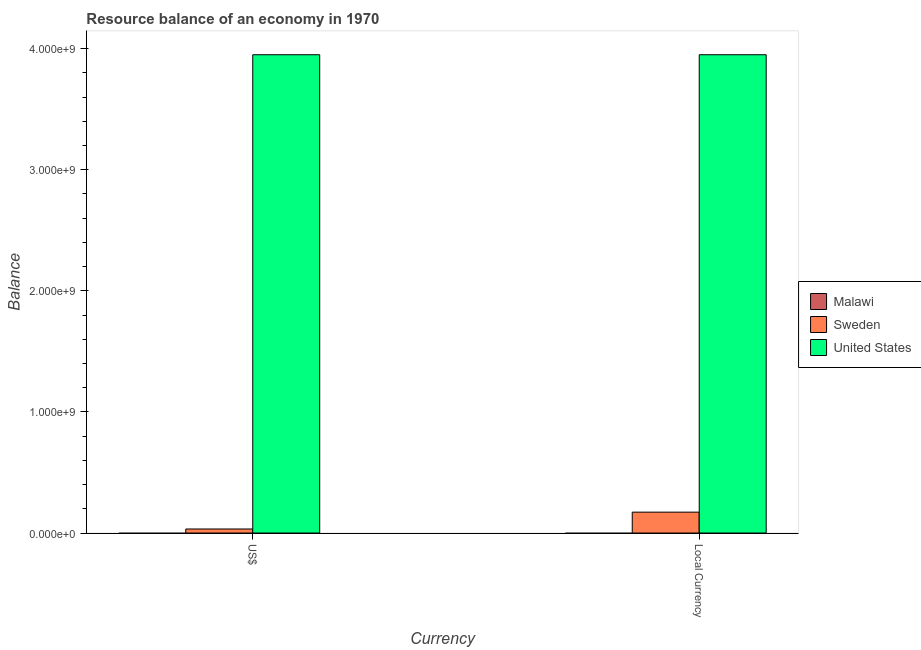How many different coloured bars are there?
Offer a terse response. 2. Are the number of bars per tick equal to the number of legend labels?
Provide a short and direct response. No. Are the number of bars on each tick of the X-axis equal?
Offer a terse response. Yes. How many bars are there on the 2nd tick from the right?
Offer a very short reply. 2. What is the label of the 2nd group of bars from the left?
Ensure brevity in your answer.  Local Currency. Across all countries, what is the maximum resource balance in us$?
Give a very brief answer. 3.95e+09. What is the total resource balance in us$ in the graph?
Keep it short and to the point. 3.98e+09. What is the difference between the resource balance in constant us$ in United States and that in Sweden?
Give a very brief answer. 3.78e+09. What is the difference between the resource balance in us$ in Sweden and the resource balance in constant us$ in Malawi?
Offer a terse response. 3.33e+07. What is the average resource balance in constant us$ per country?
Offer a very short reply. 1.37e+09. In how many countries, is the resource balance in us$ greater than 2400000000 units?
Make the answer very short. 1. What is the ratio of the resource balance in us$ in Sweden to that in United States?
Your answer should be very brief. 0.01. How many countries are there in the graph?
Keep it short and to the point. 3. What is the difference between two consecutive major ticks on the Y-axis?
Provide a succinct answer. 1.00e+09. Are the values on the major ticks of Y-axis written in scientific E-notation?
Provide a short and direct response. Yes. Does the graph contain grids?
Your response must be concise. No. How are the legend labels stacked?
Your answer should be very brief. Vertical. What is the title of the graph?
Ensure brevity in your answer.  Resource balance of an economy in 1970. Does "New Zealand" appear as one of the legend labels in the graph?
Offer a very short reply. No. What is the label or title of the X-axis?
Offer a very short reply. Currency. What is the label or title of the Y-axis?
Offer a terse response. Balance. What is the Balance of Sweden in US$?
Your response must be concise. 3.33e+07. What is the Balance of United States in US$?
Your answer should be very brief. 3.95e+09. What is the Balance in Sweden in Local Currency?
Your response must be concise. 1.72e+08. What is the Balance in United States in Local Currency?
Give a very brief answer. 3.95e+09. Across all Currency, what is the maximum Balance of Sweden?
Provide a succinct answer. 1.72e+08. Across all Currency, what is the maximum Balance of United States?
Your answer should be very brief. 3.95e+09. Across all Currency, what is the minimum Balance in Sweden?
Give a very brief answer. 3.33e+07. Across all Currency, what is the minimum Balance in United States?
Give a very brief answer. 3.95e+09. What is the total Balance of Malawi in the graph?
Ensure brevity in your answer.  0. What is the total Balance in Sweden in the graph?
Provide a succinct answer. 2.06e+08. What is the total Balance of United States in the graph?
Make the answer very short. 7.90e+09. What is the difference between the Balance in Sweden in US$ and that in Local Currency?
Ensure brevity in your answer.  -1.39e+08. What is the difference between the Balance of Sweden in US$ and the Balance of United States in Local Currency?
Offer a very short reply. -3.92e+09. What is the average Balance of Sweden per Currency?
Offer a terse response. 1.03e+08. What is the average Balance of United States per Currency?
Provide a short and direct response. 3.95e+09. What is the difference between the Balance in Sweden and Balance in United States in US$?
Offer a very short reply. -3.92e+09. What is the difference between the Balance of Sweden and Balance of United States in Local Currency?
Your answer should be compact. -3.78e+09. What is the ratio of the Balance in Sweden in US$ to that in Local Currency?
Offer a terse response. 0.19. What is the ratio of the Balance of United States in US$ to that in Local Currency?
Your answer should be very brief. 1. What is the difference between the highest and the second highest Balance in Sweden?
Keep it short and to the point. 1.39e+08. What is the difference between the highest and the second highest Balance in United States?
Ensure brevity in your answer.  0. What is the difference between the highest and the lowest Balance in Sweden?
Your answer should be very brief. 1.39e+08. What is the difference between the highest and the lowest Balance in United States?
Provide a succinct answer. 0. 